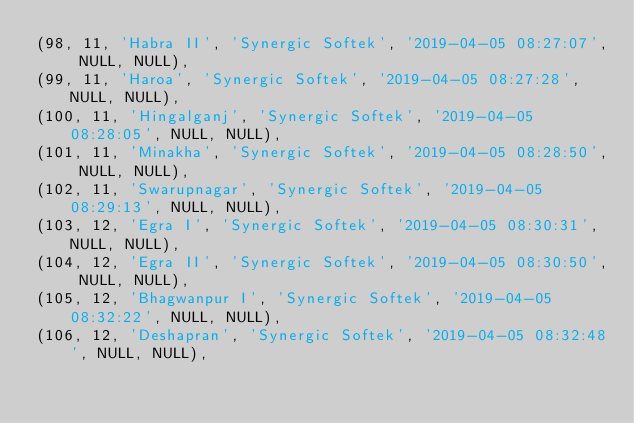<code> <loc_0><loc_0><loc_500><loc_500><_SQL_>(98, 11, 'Habra II', 'Synergic Softek', '2019-04-05 08:27:07', NULL, NULL),
(99, 11, 'Haroa', 'Synergic Softek', '2019-04-05 08:27:28', NULL, NULL),
(100, 11, 'Hingalganj', 'Synergic Softek', '2019-04-05 08:28:05', NULL, NULL),
(101, 11, 'Minakha', 'Synergic Softek', '2019-04-05 08:28:50', NULL, NULL),
(102, 11, 'Swarupnagar', 'Synergic Softek', '2019-04-05 08:29:13', NULL, NULL),
(103, 12, 'Egra I', 'Synergic Softek', '2019-04-05 08:30:31', NULL, NULL),
(104, 12, 'Egra II', 'Synergic Softek', '2019-04-05 08:30:50', NULL, NULL),
(105, 12, 'Bhagwanpur I', 'Synergic Softek', '2019-04-05 08:32:22', NULL, NULL),
(106, 12, 'Deshapran', 'Synergic Softek', '2019-04-05 08:32:48', NULL, NULL),</code> 